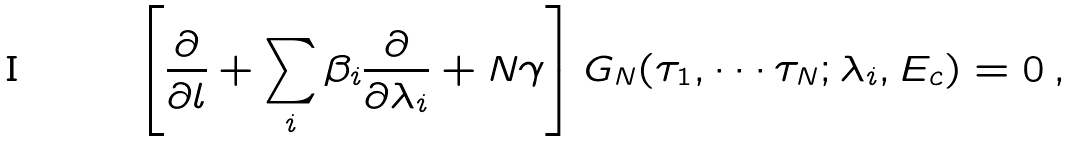<formula> <loc_0><loc_0><loc_500><loc_500>\left [ \frac { \partial } { \partial l } + \sum _ { i } \beta _ { i } \frac { \partial } { \partial \lambda _ { i } } + N \gamma \right ] G _ { N } ( \tau _ { 1 } , \cdots \tau _ { N } ; \lambda _ { i } , E _ { c } ) = 0 \, ,</formula> 